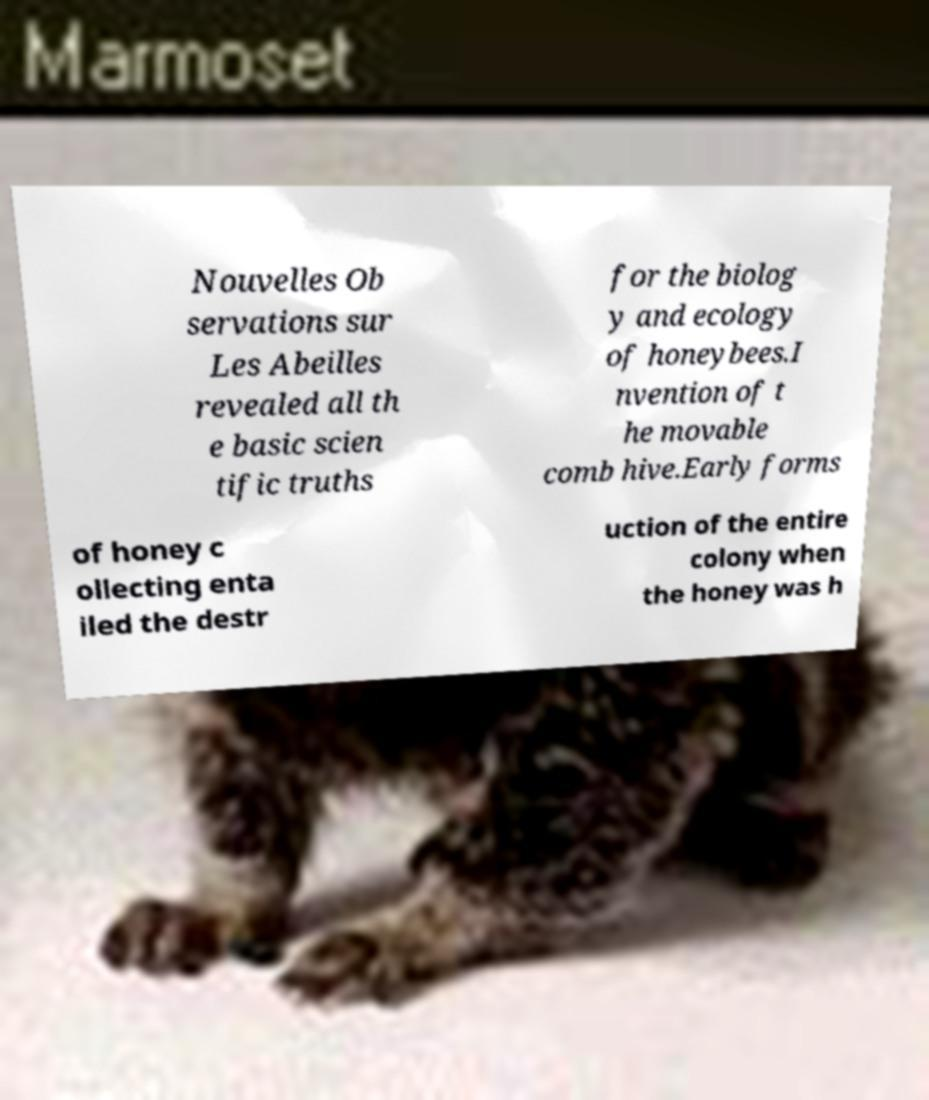I need the written content from this picture converted into text. Can you do that? Nouvelles Ob servations sur Les Abeilles revealed all th e basic scien tific truths for the biolog y and ecology of honeybees.I nvention of t he movable comb hive.Early forms of honey c ollecting enta iled the destr uction of the entire colony when the honey was h 